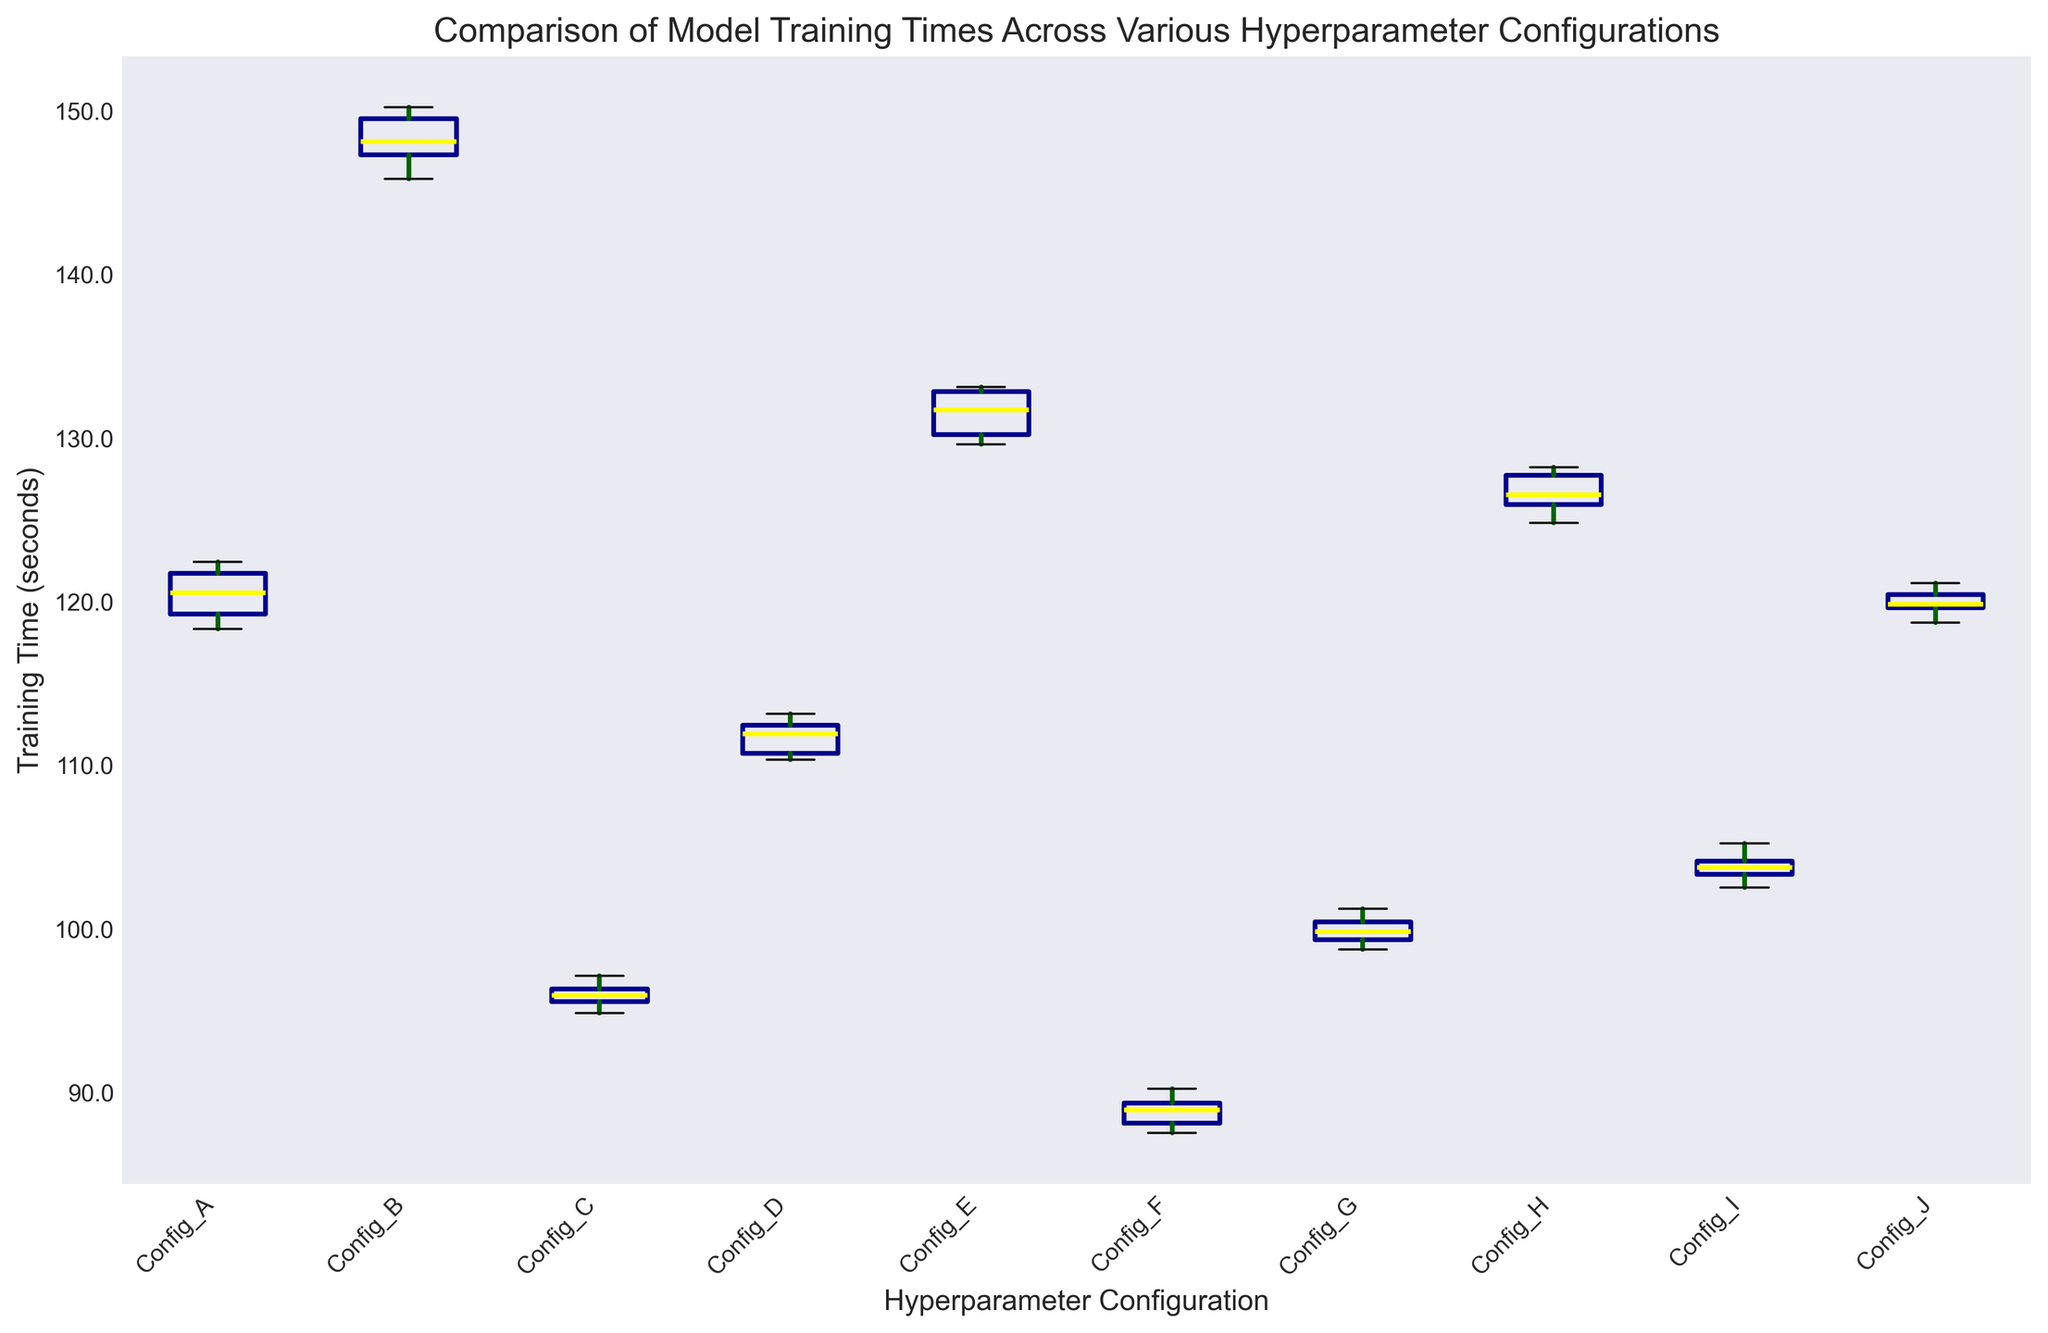Which hyperparameter configuration has the longest training times? Look at the boxplot and identify the configuration with the uppermost values. Configurations with the whiskers or boxes at higher locations indicate longer training times.
Answer: Config_B Which configuration has the smallest range in training times? Determine the range by identifying the difference between the maximum and minimum (whisker ends) for each configuration. The configuration with the shortest distance between these ends has the smallest range.
Answer: Config_C What is the median training time for Config_F? Locate the median line within the box for Config_F; this line represents the median training time.
Answer: Around 88.9 seconds Which two configurations have the most similar median training times? Compare the median lines (the yellow lines) across all the configurations. Identify two configurations where these lines are at approximately the same level.
Answer: Config_A and Config_J Which configuration has the highest variability in training times? Variability can be assessed by the length of the whiskers and the size of the box. The configuration with the most extended whiskers and biggest box indicates higher variability.
Answer: Config_B How does the training time distribution of Config_G compare to that of Config_D? Compare the positions of the boxes and whiskers of Config_G with those of Config_D, looking at the median, range, and spread.
Answer: Config_G has lower training times and a slightly smaller range compared to Config_D What is the approximate interquartile range (IQR) for Config_E? The IQR is the difference between the third quartile (top of the box) and the first quartile (bottom of the box). Visually estimate these points for Config_E and calculate the difference.
Answer: Around 3-4 seconds Are there any outliers for Config_H? Outliers are often indicated by individual points outside the whiskers. Look for any red dots or markers outside the whiskers for Config_H.
Answer: No Which configuration shows the lowest median training time? Identify the lowest positioned median line among all configurations on the boxplot.
Answer: Config_F 